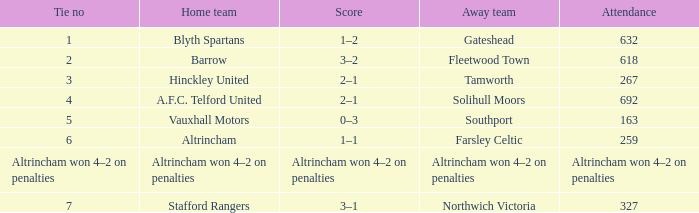What was the score when there were 7 ties? 3–1. 